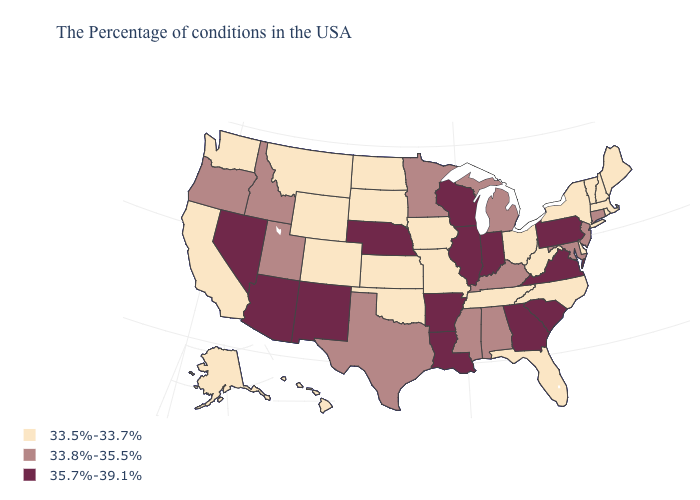What is the value of Maryland?
Quick response, please. 33.8%-35.5%. Which states hav the highest value in the MidWest?
Write a very short answer. Indiana, Wisconsin, Illinois, Nebraska. What is the value of Colorado?
Be succinct. 33.5%-33.7%. Does Delaware have the lowest value in the USA?
Concise answer only. Yes. What is the value of Virginia?
Write a very short answer. 35.7%-39.1%. What is the highest value in the USA?
Quick response, please. 35.7%-39.1%. Name the states that have a value in the range 33.8%-35.5%?
Be succinct. Connecticut, New Jersey, Maryland, Michigan, Kentucky, Alabama, Mississippi, Minnesota, Texas, Utah, Idaho, Oregon. Name the states that have a value in the range 33.5%-33.7%?
Concise answer only. Maine, Massachusetts, Rhode Island, New Hampshire, Vermont, New York, Delaware, North Carolina, West Virginia, Ohio, Florida, Tennessee, Missouri, Iowa, Kansas, Oklahoma, South Dakota, North Dakota, Wyoming, Colorado, Montana, California, Washington, Alaska, Hawaii. What is the highest value in the Northeast ?
Concise answer only. 35.7%-39.1%. Among the states that border Arizona , does Utah have the highest value?
Be succinct. No. Does South Dakota have the lowest value in the MidWest?
Quick response, please. Yes. What is the value of South Dakota?
Write a very short answer. 33.5%-33.7%. What is the value of Indiana?
Concise answer only. 35.7%-39.1%. Name the states that have a value in the range 33.8%-35.5%?
Quick response, please. Connecticut, New Jersey, Maryland, Michigan, Kentucky, Alabama, Mississippi, Minnesota, Texas, Utah, Idaho, Oregon. Does California have the highest value in the West?
Be succinct. No. 